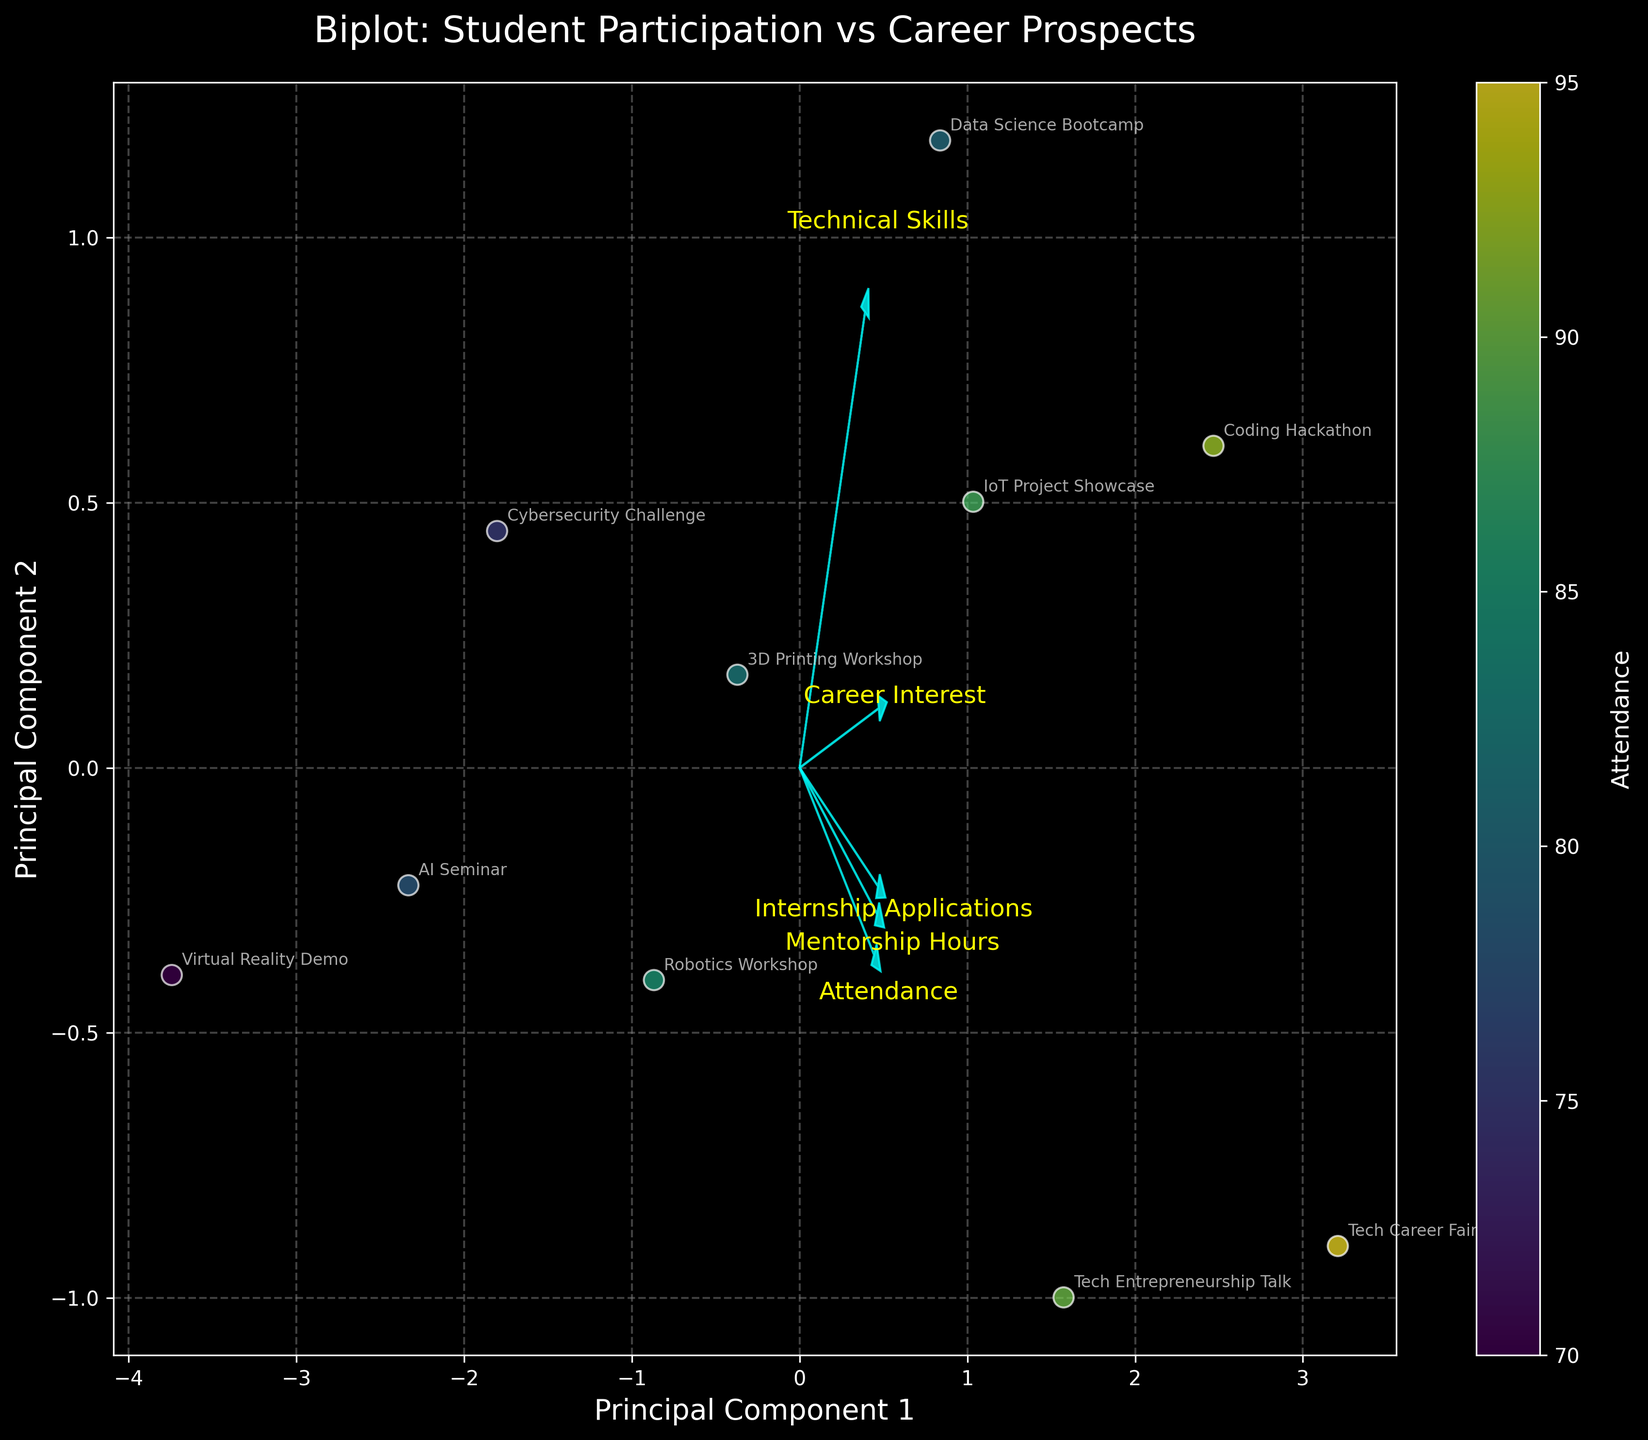What is the title of the figure? The title of a figure is typically placed at the top of the plot and describes the main topic or theme. In this case, it is "Biplot: Student Participation vs Career Prospects" as indicated near the top center of the plot.
Answer: Biplot: Student Participation vs Career Prospects What are the labels of the axes? The labels of the axes describe the data dimensions represented by each axis. For this figure, the x-axis is labeled "Principal Component 1" and the y-axis is labeled "Principal Component 2", which indicate the primary directions of the data variation.
Answer: Principal Component 1, Principal Component 2 How many data points are plotted on the biplot? Each data point on the biplot represents an event. By counting the number of points along with their annotations (labels of the events), the total number of data points can be determined. There are 10 events annotated on the plot.
Answer: 10 Which feature vector is most aligned with the first principal component? To find which feature vector is most aligned with the first principal component, we need to see which arrow extends furthest along the x-axis. By observing the directions of the arrows, "Attendance" is most aligned with the first principal component (Principal Component 1).
Answer: Attendance Which event has the highest attendance, and where is it positioned on the biplot? The coding hackathon has the highest attendance of 92. On the biplot, this event can be found by locating the data point labeled "Coding Hackathon". This point is positioned towards the upper region along the first principal component.
Answer: Coding Hackathon, upper region along Principal Component 1 Compare the relationship between "Career Interest" and "Internship Applications" on the biplot. To compare the relationship between "Career Interest" and "Internship Applications," observe the arrows representing each feature. Both vectors might point in similar directions if they have a strong correlation. If "Career Interest" and "Internship Applications" arrows are closely aligned, it indicates a strong positive relationship. By examining the plot, these vectors are reasonably aligned, suggesting they are positively correlated.
Answer: Positive correlation Which feature vector is least aligned with both principal components? The feature vector with the shortest arrow length in both principal component directions is least aligned with both. By observing the plot, "Technical Skills" has the shortest arrow length in both directions, indicating it's least aligned with both principal components.
Answer: Technical Skills Is there any event that is more closely associated with mentorship hours? An event closely associated with "Mentorship Hours" will be positioned along the direction of the corresponding arrow. By observing the plot, the "Tech Career Fair" is placed near the tip of the "Mentorship Hours" arrow, indicating a strong association.
Answer: Tech Career Fair Which event is most closely associated with "Technical Skills", and how does it compare to "Robotics Workshop"? The event closest to the "Technical Skills" arrow indicates a strong association. The "Coding Hackathon" is positioned near the "Technical Skills" arrow. Comparing this to "Robotics Workshop" which is away from the "Technical Skills" arrow, the "Coding Hackathon" has a stronger association with technical skills improvement.
Answer: Coding Hackathon, stronger association than Robotics Workshop What can be inferred about the relationship between "Attendance" and "Career Interest"? To infer the relationship, examine the alignment of the "Attendance" and "Career Interest" arrows. These arrows point in similar directions, suggesting a positive relationship. As "Attendance" increases, "Career Interest" likely increases as well.
Answer: Positive relationship 